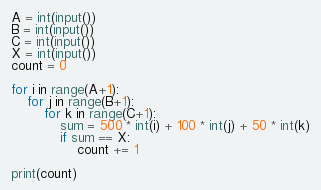<code> <loc_0><loc_0><loc_500><loc_500><_Python_>A = int(input())
B = int(input())
C = int(input())
X = int(input())
count = 0

for i in range(A+1):
    for j in range(B+1):
        for k in range(C+1):
            sum = 500 * int(i) + 100 * int(j) + 50 * int(k)
            if sum == X:
                count += 1

print(count)</code> 